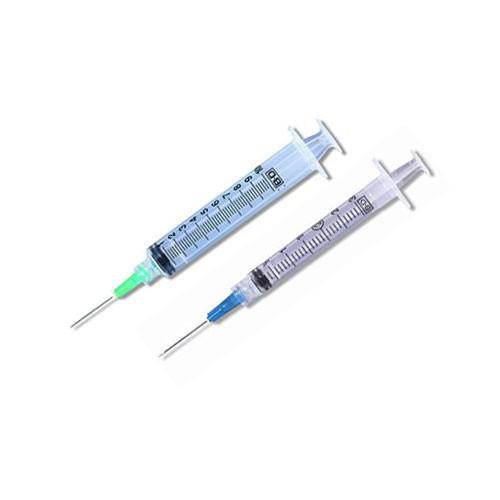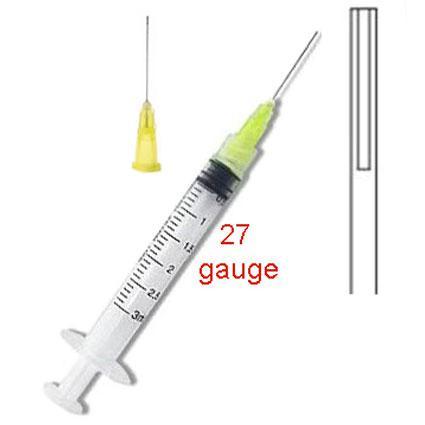The first image is the image on the left, the second image is the image on the right. Evaluate the accuracy of this statement regarding the images: "One of the images shows a single syringe and another image shows two syringes that are parallel to one another.". Is it true? Answer yes or no. Yes. The first image is the image on the left, the second image is the image on the right. Assess this claim about the two images: "There is a total of two syringes with no plastic bags.". Correct or not? Answer yes or no. No. 